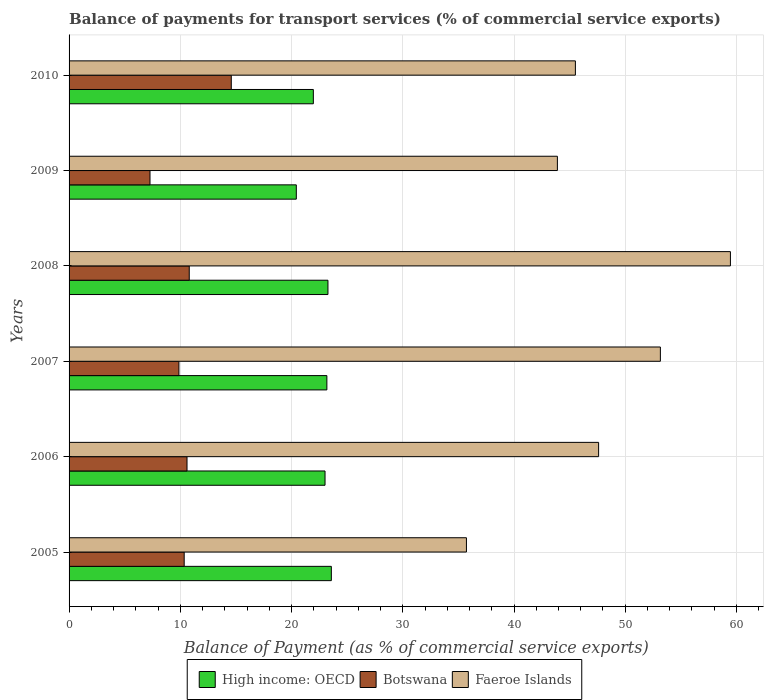How many different coloured bars are there?
Keep it short and to the point. 3. How many groups of bars are there?
Ensure brevity in your answer.  6. Are the number of bars on each tick of the Y-axis equal?
Provide a short and direct response. Yes. How many bars are there on the 5th tick from the top?
Offer a very short reply. 3. What is the label of the 3rd group of bars from the top?
Give a very brief answer. 2008. What is the balance of payments for transport services in Faeroe Islands in 2006?
Offer a terse response. 47.61. Across all years, what is the maximum balance of payments for transport services in Botswana?
Keep it short and to the point. 14.58. Across all years, what is the minimum balance of payments for transport services in Faeroe Islands?
Your response must be concise. 35.72. In which year was the balance of payments for transport services in High income: OECD minimum?
Your answer should be very brief. 2009. What is the total balance of payments for transport services in Faeroe Islands in the graph?
Keep it short and to the point. 285.37. What is the difference between the balance of payments for transport services in High income: OECD in 2006 and that in 2007?
Provide a short and direct response. -0.17. What is the difference between the balance of payments for transport services in High income: OECD in 2005 and the balance of payments for transport services in Botswana in 2009?
Give a very brief answer. 16.3. What is the average balance of payments for transport services in Faeroe Islands per year?
Provide a succinct answer. 47.56. In the year 2009, what is the difference between the balance of payments for transport services in Botswana and balance of payments for transport services in Faeroe Islands?
Offer a terse response. -36.62. What is the ratio of the balance of payments for transport services in Faeroe Islands in 2009 to that in 2010?
Offer a very short reply. 0.96. Is the balance of payments for transport services in Faeroe Islands in 2005 less than that in 2008?
Ensure brevity in your answer.  Yes. What is the difference between the highest and the second highest balance of payments for transport services in Faeroe Islands?
Provide a short and direct response. 6.3. What is the difference between the highest and the lowest balance of payments for transport services in High income: OECD?
Provide a short and direct response. 3.15. In how many years, is the balance of payments for transport services in Botswana greater than the average balance of payments for transport services in Botswana taken over all years?
Provide a short and direct response. 3. Is the sum of the balance of payments for transport services in High income: OECD in 2005 and 2008 greater than the maximum balance of payments for transport services in Faeroe Islands across all years?
Offer a very short reply. No. What does the 2nd bar from the top in 2006 represents?
Your answer should be very brief. Botswana. What does the 2nd bar from the bottom in 2006 represents?
Give a very brief answer. Botswana. Is it the case that in every year, the sum of the balance of payments for transport services in Faeroe Islands and balance of payments for transport services in Botswana is greater than the balance of payments for transport services in High income: OECD?
Offer a very short reply. Yes. How many bars are there?
Offer a terse response. 18. How many years are there in the graph?
Offer a terse response. 6. What is the difference between two consecutive major ticks on the X-axis?
Provide a succinct answer. 10. Are the values on the major ticks of X-axis written in scientific E-notation?
Offer a very short reply. No. What is the title of the graph?
Offer a very short reply. Balance of payments for transport services (% of commercial service exports). Does "Burundi" appear as one of the legend labels in the graph?
Provide a short and direct response. No. What is the label or title of the X-axis?
Give a very brief answer. Balance of Payment (as % of commercial service exports). What is the label or title of the Y-axis?
Ensure brevity in your answer.  Years. What is the Balance of Payment (as % of commercial service exports) in High income: OECD in 2005?
Keep it short and to the point. 23.58. What is the Balance of Payment (as % of commercial service exports) of Botswana in 2005?
Offer a terse response. 10.35. What is the Balance of Payment (as % of commercial service exports) of Faeroe Islands in 2005?
Your response must be concise. 35.72. What is the Balance of Payment (as % of commercial service exports) of High income: OECD in 2006?
Provide a short and direct response. 23.01. What is the Balance of Payment (as % of commercial service exports) in Botswana in 2006?
Your response must be concise. 10.6. What is the Balance of Payment (as % of commercial service exports) of Faeroe Islands in 2006?
Your answer should be compact. 47.61. What is the Balance of Payment (as % of commercial service exports) of High income: OECD in 2007?
Your response must be concise. 23.18. What is the Balance of Payment (as % of commercial service exports) of Botswana in 2007?
Keep it short and to the point. 9.88. What is the Balance of Payment (as % of commercial service exports) in Faeroe Islands in 2007?
Provide a succinct answer. 53.16. What is the Balance of Payment (as % of commercial service exports) of High income: OECD in 2008?
Offer a very short reply. 23.27. What is the Balance of Payment (as % of commercial service exports) of Botswana in 2008?
Keep it short and to the point. 10.8. What is the Balance of Payment (as % of commercial service exports) of Faeroe Islands in 2008?
Ensure brevity in your answer.  59.46. What is the Balance of Payment (as % of commercial service exports) in High income: OECD in 2009?
Ensure brevity in your answer.  20.43. What is the Balance of Payment (as % of commercial service exports) of Botswana in 2009?
Offer a terse response. 7.28. What is the Balance of Payment (as % of commercial service exports) of Faeroe Islands in 2009?
Offer a very short reply. 43.9. What is the Balance of Payment (as % of commercial service exports) of High income: OECD in 2010?
Offer a terse response. 21.96. What is the Balance of Payment (as % of commercial service exports) of Botswana in 2010?
Your answer should be compact. 14.58. What is the Balance of Payment (as % of commercial service exports) in Faeroe Islands in 2010?
Provide a short and direct response. 45.52. Across all years, what is the maximum Balance of Payment (as % of commercial service exports) of High income: OECD?
Make the answer very short. 23.58. Across all years, what is the maximum Balance of Payment (as % of commercial service exports) of Botswana?
Give a very brief answer. 14.58. Across all years, what is the maximum Balance of Payment (as % of commercial service exports) in Faeroe Islands?
Give a very brief answer. 59.46. Across all years, what is the minimum Balance of Payment (as % of commercial service exports) in High income: OECD?
Make the answer very short. 20.43. Across all years, what is the minimum Balance of Payment (as % of commercial service exports) of Botswana?
Provide a succinct answer. 7.28. Across all years, what is the minimum Balance of Payment (as % of commercial service exports) of Faeroe Islands?
Provide a short and direct response. 35.72. What is the total Balance of Payment (as % of commercial service exports) in High income: OECD in the graph?
Your answer should be compact. 135.43. What is the total Balance of Payment (as % of commercial service exports) in Botswana in the graph?
Offer a very short reply. 63.49. What is the total Balance of Payment (as % of commercial service exports) of Faeroe Islands in the graph?
Offer a terse response. 285.37. What is the difference between the Balance of Payment (as % of commercial service exports) in High income: OECD in 2005 and that in 2006?
Keep it short and to the point. 0.57. What is the difference between the Balance of Payment (as % of commercial service exports) of Botswana in 2005 and that in 2006?
Your answer should be compact. -0.25. What is the difference between the Balance of Payment (as % of commercial service exports) of Faeroe Islands in 2005 and that in 2006?
Offer a very short reply. -11.88. What is the difference between the Balance of Payment (as % of commercial service exports) of High income: OECD in 2005 and that in 2007?
Provide a succinct answer. 0.4. What is the difference between the Balance of Payment (as % of commercial service exports) of Botswana in 2005 and that in 2007?
Your response must be concise. 0.47. What is the difference between the Balance of Payment (as % of commercial service exports) in Faeroe Islands in 2005 and that in 2007?
Provide a succinct answer. -17.44. What is the difference between the Balance of Payment (as % of commercial service exports) in High income: OECD in 2005 and that in 2008?
Make the answer very short. 0.31. What is the difference between the Balance of Payment (as % of commercial service exports) in Botswana in 2005 and that in 2008?
Offer a terse response. -0.45. What is the difference between the Balance of Payment (as % of commercial service exports) of Faeroe Islands in 2005 and that in 2008?
Ensure brevity in your answer.  -23.73. What is the difference between the Balance of Payment (as % of commercial service exports) of High income: OECD in 2005 and that in 2009?
Your answer should be very brief. 3.15. What is the difference between the Balance of Payment (as % of commercial service exports) of Botswana in 2005 and that in 2009?
Provide a short and direct response. 3.07. What is the difference between the Balance of Payment (as % of commercial service exports) of Faeroe Islands in 2005 and that in 2009?
Provide a succinct answer. -8.18. What is the difference between the Balance of Payment (as % of commercial service exports) of High income: OECD in 2005 and that in 2010?
Your response must be concise. 1.62. What is the difference between the Balance of Payment (as % of commercial service exports) in Botswana in 2005 and that in 2010?
Provide a short and direct response. -4.23. What is the difference between the Balance of Payment (as % of commercial service exports) in Faeroe Islands in 2005 and that in 2010?
Provide a succinct answer. -9.8. What is the difference between the Balance of Payment (as % of commercial service exports) of High income: OECD in 2006 and that in 2007?
Your answer should be very brief. -0.17. What is the difference between the Balance of Payment (as % of commercial service exports) in Botswana in 2006 and that in 2007?
Provide a short and direct response. 0.73. What is the difference between the Balance of Payment (as % of commercial service exports) in Faeroe Islands in 2006 and that in 2007?
Your answer should be very brief. -5.55. What is the difference between the Balance of Payment (as % of commercial service exports) in High income: OECD in 2006 and that in 2008?
Your response must be concise. -0.26. What is the difference between the Balance of Payment (as % of commercial service exports) in Botswana in 2006 and that in 2008?
Ensure brevity in your answer.  -0.2. What is the difference between the Balance of Payment (as % of commercial service exports) in Faeroe Islands in 2006 and that in 2008?
Provide a short and direct response. -11.85. What is the difference between the Balance of Payment (as % of commercial service exports) in High income: OECD in 2006 and that in 2009?
Ensure brevity in your answer.  2.58. What is the difference between the Balance of Payment (as % of commercial service exports) of Botswana in 2006 and that in 2009?
Make the answer very short. 3.33. What is the difference between the Balance of Payment (as % of commercial service exports) in Faeroe Islands in 2006 and that in 2009?
Your answer should be compact. 3.71. What is the difference between the Balance of Payment (as % of commercial service exports) in High income: OECD in 2006 and that in 2010?
Your answer should be compact. 1.05. What is the difference between the Balance of Payment (as % of commercial service exports) in Botswana in 2006 and that in 2010?
Give a very brief answer. -3.98. What is the difference between the Balance of Payment (as % of commercial service exports) of Faeroe Islands in 2006 and that in 2010?
Offer a very short reply. 2.09. What is the difference between the Balance of Payment (as % of commercial service exports) of High income: OECD in 2007 and that in 2008?
Ensure brevity in your answer.  -0.1. What is the difference between the Balance of Payment (as % of commercial service exports) in Botswana in 2007 and that in 2008?
Provide a succinct answer. -0.93. What is the difference between the Balance of Payment (as % of commercial service exports) in Faeroe Islands in 2007 and that in 2008?
Ensure brevity in your answer.  -6.3. What is the difference between the Balance of Payment (as % of commercial service exports) of High income: OECD in 2007 and that in 2009?
Keep it short and to the point. 2.75. What is the difference between the Balance of Payment (as % of commercial service exports) of Botswana in 2007 and that in 2009?
Offer a very short reply. 2.6. What is the difference between the Balance of Payment (as % of commercial service exports) in Faeroe Islands in 2007 and that in 2009?
Your response must be concise. 9.26. What is the difference between the Balance of Payment (as % of commercial service exports) of High income: OECD in 2007 and that in 2010?
Offer a very short reply. 1.22. What is the difference between the Balance of Payment (as % of commercial service exports) of Botswana in 2007 and that in 2010?
Make the answer very short. -4.71. What is the difference between the Balance of Payment (as % of commercial service exports) of Faeroe Islands in 2007 and that in 2010?
Make the answer very short. 7.64. What is the difference between the Balance of Payment (as % of commercial service exports) in High income: OECD in 2008 and that in 2009?
Your response must be concise. 2.84. What is the difference between the Balance of Payment (as % of commercial service exports) of Botswana in 2008 and that in 2009?
Your answer should be very brief. 3.53. What is the difference between the Balance of Payment (as % of commercial service exports) in Faeroe Islands in 2008 and that in 2009?
Your answer should be very brief. 15.56. What is the difference between the Balance of Payment (as % of commercial service exports) in High income: OECD in 2008 and that in 2010?
Make the answer very short. 1.31. What is the difference between the Balance of Payment (as % of commercial service exports) in Botswana in 2008 and that in 2010?
Offer a terse response. -3.78. What is the difference between the Balance of Payment (as % of commercial service exports) in Faeroe Islands in 2008 and that in 2010?
Your response must be concise. 13.94. What is the difference between the Balance of Payment (as % of commercial service exports) of High income: OECD in 2009 and that in 2010?
Your answer should be very brief. -1.53. What is the difference between the Balance of Payment (as % of commercial service exports) of Botswana in 2009 and that in 2010?
Offer a terse response. -7.31. What is the difference between the Balance of Payment (as % of commercial service exports) in Faeroe Islands in 2009 and that in 2010?
Provide a short and direct response. -1.62. What is the difference between the Balance of Payment (as % of commercial service exports) of High income: OECD in 2005 and the Balance of Payment (as % of commercial service exports) of Botswana in 2006?
Ensure brevity in your answer.  12.98. What is the difference between the Balance of Payment (as % of commercial service exports) in High income: OECD in 2005 and the Balance of Payment (as % of commercial service exports) in Faeroe Islands in 2006?
Provide a short and direct response. -24.03. What is the difference between the Balance of Payment (as % of commercial service exports) of Botswana in 2005 and the Balance of Payment (as % of commercial service exports) of Faeroe Islands in 2006?
Provide a succinct answer. -37.26. What is the difference between the Balance of Payment (as % of commercial service exports) of High income: OECD in 2005 and the Balance of Payment (as % of commercial service exports) of Botswana in 2007?
Your answer should be very brief. 13.7. What is the difference between the Balance of Payment (as % of commercial service exports) of High income: OECD in 2005 and the Balance of Payment (as % of commercial service exports) of Faeroe Islands in 2007?
Your response must be concise. -29.58. What is the difference between the Balance of Payment (as % of commercial service exports) of Botswana in 2005 and the Balance of Payment (as % of commercial service exports) of Faeroe Islands in 2007?
Make the answer very short. -42.81. What is the difference between the Balance of Payment (as % of commercial service exports) of High income: OECD in 2005 and the Balance of Payment (as % of commercial service exports) of Botswana in 2008?
Your answer should be compact. 12.77. What is the difference between the Balance of Payment (as % of commercial service exports) of High income: OECD in 2005 and the Balance of Payment (as % of commercial service exports) of Faeroe Islands in 2008?
Your response must be concise. -35.88. What is the difference between the Balance of Payment (as % of commercial service exports) in Botswana in 2005 and the Balance of Payment (as % of commercial service exports) in Faeroe Islands in 2008?
Give a very brief answer. -49.11. What is the difference between the Balance of Payment (as % of commercial service exports) in High income: OECD in 2005 and the Balance of Payment (as % of commercial service exports) in Botswana in 2009?
Provide a short and direct response. 16.3. What is the difference between the Balance of Payment (as % of commercial service exports) of High income: OECD in 2005 and the Balance of Payment (as % of commercial service exports) of Faeroe Islands in 2009?
Offer a very short reply. -20.32. What is the difference between the Balance of Payment (as % of commercial service exports) in Botswana in 2005 and the Balance of Payment (as % of commercial service exports) in Faeroe Islands in 2009?
Your answer should be very brief. -33.55. What is the difference between the Balance of Payment (as % of commercial service exports) of High income: OECD in 2005 and the Balance of Payment (as % of commercial service exports) of Botswana in 2010?
Give a very brief answer. 9. What is the difference between the Balance of Payment (as % of commercial service exports) in High income: OECD in 2005 and the Balance of Payment (as % of commercial service exports) in Faeroe Islands in 2010?
Provide a succinct answer. -21.94. What is the difference between the Balance of Payment (as % of commercial service exports) of Botswana in 2005 and the Balance of Payment (as % of commercial service exports) of Faeroe Islands in 2010?
Provide a succinct answer. -35.17. What is the difference between the Balance of Payment (as % of commercial service exports) of High income: OECD in 2006 and the Balance of Payment (as % of commercial service exports) of Botswana in 2007?
Your answer should be compact. 13.14. What is the difference between the Balance of Payment (as % of commercial service exports) in High income: OECD in 2006 and the Balance of Payment (as % of commercial service exports) in Faeroe Islands in 2007?
Make the answer very short. -30.15. What is the difference between the Balance of Payment (as % of commercial service exports) of Botswana in 2006 and the Balance of Payment (as % of commercial service exports) of Faeroe Islands in 2007?
Give a very brief answer. -42.56. What is the difference between the Balance of Payment (as % of commercial service exports) of High income: OECD in 2006 and the Balance of Payment (as % of commercial service exports) of Botswana in 2008?
Your answer should be compact. 12.21. What is the difference between the Balance of Payment (as % of commercial service exports) of High income: OECD in 2006 and the Balance of Payment (as % of commercial service exports) of Faeroe Islands in 2008?
Your answer should be very brief. -36.45. What is the difference between the Balance of Payment (as % of commercial service exports) of Botswana in 2006 and the Balance of Payment (as % of commercial service exports) of Faeroe Islands in 2008?
Ensure brevity in your answer.  -48.85. What is the difference between the Balance of Payment (as % of commercial service exports) of High income: OECD in 2006 and the Balance of Payment (as % of commercial service exports) of Botswana in 2009?
Offer a very short reply. 15.74. What is the difference between the Balance of Payment (as % of commercial service exports) of High income: OECD in 2006 and the Balance of Payment (as % of commercial service exports) of Faeroe Islands in 2009?
Your response must be concise. -20.89. What is the difference between the Balance of Payment (as % of commercial service exports) in Botswana in 2006 and the Balance of Payment (as % of commercial service exports) in Faeroe Islands in 2009?
Offer a terse response. -33.3. What is the difference between the Balance of Payment (as % of commercial service exports) in High income: OECD in 2006 and the Balance of Payment (as % of commercial service exports) in Botswana in 2010?
Your answer should be compact. 8.43. What is the difference between the Balance of Payment (as % of commercial service exports) of High income: OECD in 2006 and the Balance of Payment (as % of commercial service exports) of Faeroe Islands in 2010?
Offer a terse response. -22.51. What is the difference between the Balance of Payment (as % of commercial service exports) in Botswana in 2006 and the Balance of Payment (as % of commercial service exports) in Faeroe Islands in 2010?
Your answer should be very brief. -34.92. What is the difference between the Balance of Payment (as % of commercial service exports) of High income: OECD in 2007 and the Balance of Payment (as % of commercial service exports) of Botswana in 2008?
Ensure brevity in your answer.  12.37. What is the difference between the Balance of Payment (as % of commercial service exports) in High income: OECD in 2007 and the Balance of Payment (as % of commercial service exports) in Faeroe Islands in 2008?
Make the answer very short. -36.28. What is the difference between the Balance of Payment (as % of commercial service exports) of Botswana in 2007 and the Balance of Payment (as % of commercial service exports) of Faeroe Islands in 2008?
Ensure brevity in your answer.  -49.58. What is the difference between the Balance of Payment (as % of commercial service exports) of High income: OECD in 2007 and the Balance of Payment (as % of commercial service exports) of Botswana in 2009?
Your answer should be compact. 15.9. What is the difference between the Balance of Payment (as % of commercial service exports) of High income: OECD in 2007 and the Balance of Payment (as % of commercial service exports) of Faeroe Islands in 2009?
Offer a very short reply. -20.72. What is the difference between the Balance of Payment (as % of commercial service exports) of Botswana in 2007 and the Balance of Payment (as % of commercial service exports) of Faeroe Islands in 2009?
Offer a very short reply. -34.02. What is the difference between the Balance of Payment (as % of commercial service exports) of High income: OECD in 2007 and the Balance of Payment (as % of commercial service exports) of Botswana in 2010?
Make the answer very short. 8.59. What is the difference between the Balance of Payment (as % of commercial service exports) of High income: OECD in 2007 and the Balance of Payment (as % of commercial service exports) of Faeroe Islands in 2010?
Keep it short and to the point. -22.34. What is the difference between the Balance of Payment (as % of commercial service exports) of Botswana in 2007 and the Balance of Payment (as % of commercial service exports) of Faeroe Islands in 2010?
Provide a succinct answer. -35.64. What is the difference between the Balance of Payment (as % of commercial service exports) of High income: OECD in 2008 and the Balance of Payment (as % of commercial service exports) of Botswana in 2009?
Your answer should be compact. 16. What is the difference between the Balance of Payment (as % of commercial service exports) in High income: OECD in 2008 and the Balance of Payment (as % of commercial service exports) in Faeroe Islands in 2009?
Offer a very short reply. -20.63. What is the difference between the Balance of Payment (as % of commercial service exports) in Botswana in 2008 and the Balance of Payment (as % of commercial service exports) in Faeroe Islands in 2009?
Ensure brevity in your answer.  -33.1. What is the difference between the Balance of Payment (as % of commercial service exports) in High income: OECD in 2008 and the Balance of Payment (as % of commercial service exports) in Botswana in 2010?
Ensure brevity in your answer.  8.69. What is the difference between the Balance of Payment (as % of commercial service exports) of High income: OECD in 2008 and the Balance of Payment (as % of commercial service exports) of Faeroe Islands in 2010?
Your response must be concise. -22.25. What is the difference between the Balance of Payment (as % of commercial service exports) in Botswana in 2008 and the Balance of Payment (as % of commercial service exports) in Faeroe Islands in 2010?
Give a very brief answer. -34.71. What is the difference between the Balance of Payment (as % of commercial service exports) in High income: OECD in 2009 and the Balance of Payment (as % of commercial service exports) in Botswana in 2010?
Make the answer very short. 5.85. What is the difference between the Balance of Payment (as % of commercial service exports) in High income: OECD in 2009 and the Balance of Payment (as % of commercial service exports) in Faeroe Islands in 2010?
Your answer should be very brief. -25.09. What is the difference between the Balance of Payment (as % of commercial service exports) in Botswana in 2009 and the Balance of Payment (as % of commercial service exports) in Faeroe Islands in 2010?
Make the answer very short. -38.24. What is the average Balance of Payment (as % of commercial service exports) in High income: OECD per year?
Your answer should be very brief. 22.57. What is the average Balance of Payment (as % of commercial service exports) in Botswana per year?
Offer a very short reply. 10.58. What is the average Balance of Payment (as % of commercial service exports) of Faeroe Islands per year?
Make the answer very short. 47.56. In the year 2005, what is the difference between the Balance of Payment (as % of commercial service exports) in High income: OECD and Balance of Payment (as % of commercial service exports) in Botswana?
Provide a short and direct response. 13.23. In the year 2005, what is the difference between the Balance of Payment (as % of commercial service exports) in High income: OECD and Balance of Payment (as % of commercial service exports) in Faeroe Islands?
Make the answer very short. -12.14. In the year 2005, what is the difference between the Balance of Payment (as % of commercial service exports) of Botswana and Balance of Payment (as % of commercial service exports) of Faeroe Islands?
Offer a very short reply. -25.37. In the year 2006, what is the difference between the Balance of Payment (as % of commercial service exports) of High income: OECD and Balance of Payment (as % of commercial service exports) of Botswana?
Your answer should be compact. 12.41. In the year 2006, what is the difference between the Balance of Payment (as % of commercial service exports) of High income: OECD and Balance of Payment (as % of commercial service exports) of Faeroe Islands?
Keep it short and to the point. -24.59. In the year 2006, what is the difference between the Balance of Payment (as % of commercial service exports) in Botswana and Balance of Payment (as % of commercial service exports) in Faeroe Islands?
Ensure brevity in your answer.  -37. In the year 2007, what is the difference between the Balance of Payment (as % of commercial service exports) of High income: OECD and Balance of Payment (as % of commercial service exports) of Botswana?
Keep it short and to the point. 13.3. In the year 2007, what is the difference between the Balance of Payment (as % of commercial service exports) in High income: OECD and Balance of Payment (as % of commercial service exports) in Faeroe Islands?
Provide a succinct answer. -29.98. In the year 2007, what is the difference between the Balance of Payment (as % of commercial service exports) of Botswana and Balance of Payment (as % of commercial service exports) of Faeroe Islands?
Provide a succinct answer. -43.28. In the year 2008, what is the difference between the Balance of Payment (as % of commercial service exports) in High income: OECD and Balance of Payment (as % of commercial service exports) in Botswana?
Your answer should be very brief. 12.47. In the year 2008, what is the difference between the Balance of Payment (as % of commercial service exports) in High income: OECD and Balance of Payment (as % of commercial service exports) in Faeroe Islands?
Your answer should be very brief. -36.18. In the year 2008, what is the difference between the Balance of Payment (as % of commercial service exports) of Botswana and Balance of Payment (as % of commercial service exports) of Faeroe Islands?
Your answer should be very brief. -48.65. In the year 2009, what is the difference between the Balance of Payment (as % of commercial service exports) of High income: OECD and Balance of Payment (as % of commercial service exports) of Botswana?
Your response must be concise. 13.15. In the year 2009, what is the difference between the Balance of Payment (as % of commercial service exports) in High income: OECD and Balance of Payment (as % of commercial service exports) in Faeroe Islands?
Your answer should be very brief. -23.47. In the year 2009, what is the difference between the Balance of Payment (as % of commercial service exports) in Botswana and Balance of Payment (as % of commercial service exports) in Faeroe Islands?
Ensure brevity in your answer.  -36.62. In the year 2010, what is the difference between the Balance of Payment (as % of commercial service exports) in High income: OECD and Balance of Payment (as % of commercial service exports) in Botswana?
Your response must be concise. 7.38. In the year 2010, what is the difference between the Balance of Payment (as % of commercial service exports) of High income: OECD and Balance of Payment (as % of commercial service exports) of Faeroe Islands?
Provide a succinct answer. -23.56. In the year 2010, what is the difference between the Balance of Payment (as % of commercial service exports) in Botswana and Balance of Payment (as % of commercial service exports) in Faeroe Islands?
Make the answer very short. -30.94. What is the ratio of the Balance of Payment (as % of commercial service exports) of High income: OECD in 2005 to that in 2006?
Offer a very short reply. 1.02. What is the ratio of the Balance of Payment (as % of commercial service exports) in Faeroe Islands in 2005 to that in 2006?
Your answer should be compact. 0.75. What is the ratio of the Balance of Payment (as % of commercial service exports) of High income: OECD in 2005 to that in 2007?
Keep it short and to the point. 1.02. What is the ratio of the Balance of Payment (as % of commercial service exports) of Botswana in 2005 to that in 2007?
Give a very brief answer. 1.05. What is the ratio of the Balance of Payment (as % of commercial service exports) in Faeroe Islands in 2005 to that in 2007?
Offer a terse response. 0.67. What is the ratio of the Balance of Payment (as % of commercial service exports) in High income: OECD in 2005 to that in 2008?
Provide a succinct answer. 1.01. What is the ratio of the Balance of Payment (as % of commercial service exports) of Botswana in 2005 to that in 2008?
Offer a very short reply. 0.96. What is the ratio of the Balance of Payment (as % of commercial service exports) of Faeroe Islands in 2005 to that in 2008?
Offer a terse response. 0.6. What is the ratio of the Balance of Payment (as % of commercial service exports) in High income: OECD in 2005 to that in 2009?
Provide a succinct answer. 1.15. What is the ratio of the Balance of Payment (as % of commercial service exports) of Botswana in 2005 to that in 2009?
Ensure brevity in your answer.  1.42. What is the ratio of the Balance of Payment (as % of commercial service exports) of Faeroe Islands in 2005 to that in 2009?
Provide a succinct answer. 0.81. What is the ratio of the Balance of Payment (as % of commercial service exports) in High income: OECD in 2005 to that in 2010?
Ensure brevity in your answer.  1.07. What is the ratio of the Balance of Payment (as % of commercial service exports) in Botswana in 2005 to that in 2010?
Make the answer very short. 0.71. What is the ratio of the Balance of Payment (as % of commercial service exports) in Faeroe Islands in 2005 to that in 2010?
Keep it short and to the point. 0.78. What is the ratio of the Balance of Payment (as % of commercial service exports) of Botswana in 2006 to that in 2007?
Provide a short and direct response. 1.07. What is the ratio of the Balance of Payment (as % of commercial service exports) of Faeroe Islands in 2006 to that in 2007?
Your response must be concise. 0.9. What is the ratio of the Balance of Payment (as % of commercial service exports) of Botswana in 2006 to that in 2008?
Make the answer very short. 0.98. What is the ratio of the Balance of Payment (as % of commercial service exports) in Faeroe Islands in 2006 to that in 2008?
Provide a succinct answer. 0.8. What is the ratio of the Balance of Payment (as % of commercial service exports) of High income: OECD in 2006 to that in 2009?
Ensure brevity in your answer.  1.13. What is the ratio of the Balance of Payment (as % of commercial service exports) in Botswana in 2006 to that in 2009?
Give a very brief answer. 1.46. What is the ratio of the Balance of Payment (as % of commercial service exports) of Faeroe Islands in 2006 to that in 2009?
Keep it short and to the point. 1.08. What is the ratio of the Balance of Payment (as % of commercial service exports) in High income: OECD in 2006 to that in 2010?
Provide a short and direct response. 1.05. What is the ratio of the Balance of Payment (as % of commercial service exports) of Botswana in 2006 to that in 2010?
Ensure brevity in your answer.  0.73. What is the ratio of the Balance of Payment (as % of commercial service exports) in Faeroe Islands in 2006 to that in 2010?
Your response must be concise. 1.05. What is the ratio of the Balance of Payment (as % of commercial service exports) of Botswana in 2007 to that in 2008?
Offer a very short reply. 0.91. What is the ratio of the Balance of Payment (as % of commercial service exports) of Faeroe Islands in 2007 to that in 2008?
Your answer should be compact. 0.89. What is the ratio of the Balance of Payment (as % of commercial service exports) in High income: OECD in 2007 to that in 2009?
Your answer should be very brief. 1.13. What is the ratio of the Balance of Payment (as % of commercial service exports) in Botswana in 2007 to that in 2009?
Your response must be concise. 1.36. What is the ratio of the Balance of Payment (as % of commercial service exports) of Faeroe Islands in 2007 to that in 2009?
Provide a short and direct response. 1.21. What is the ratio of the Balance of Payment (as % of commercial service exports) of High income: OECD in 2007 to that in 2010?
Ensure brevity in your answer.  1.06. What is the ratio of the Balance of Payment (as % of commercial service exports) of Botswana in 2007 to that in 2010?
Provide a succinct answer. 0.68. What is the ratio of the Balance of Payment (as % of commercial service exports) of Faeroe Islands in 2007 to that in 2010?
Make the answer very short. 1.17. What is the ratio of the Balance of Payment (as % of commercial service exports) in High income: OECD in 2008 to that in 2009?
Ensure brevity in your answer.  1.14. What is the ratio of the Balance of Payment (as % of commercial service exports) of Botswana in 2008 to that in 2009?
Offer a very short reply. 1.48. What is the ratio of the Balance of Payment (as % of commercial service exports) of Faeroe Islands in 2008 to that in 2009?
Provide a short and direct response. 1.35. What is the ratio of the Balance of Payment (as % of commercial service exports) of High income: OECD in 2008 to that in 2010?
Offer a very short reply. 1.06. What is the ratio of the Balance of Payment (as % of commercial service exports) in Botswana in 2008 to that in 2010?
Your answer should be compact. 0.74. What is the ratio of the Balance of Payment (as % of commercial service exports) in Faeroe Islands in 2008 to that in 2010?
Ensure brevity in your answer.  1.31. What is the ratio of the Balance of Payment (as % of commercial service exports) of High income: OECD in 2009 to that in 2010?
Ensure brevity in your answer.  0.93. What is the ratio of the Balance of Payment (as % of commercial service exports) in Botswana in 2009 to that in 2010?
Provide a succinct answer. 0.5. What is the ratio of the Balance of Payment (as % of commercial service exports) of Faeroe Islands in 2009 to that in 2010?
Give a very brief answer. 0.96. What is the difference between the highest and the second highest Balance of Payment (as % of commercial service exports) of High income: OECD?
Offer a terse response. 0.31. What is the difference between the highest and the second highest Balance of Payment (as % of commercial service exports) in Botswana?
Provide a succinct answer. 3.78. What is the difference between the highest and the second highest Balance of Payment (as % of commercial service exports) of Faeroe Islands?
Provide a succinct answer. 6.3. What is the difference between the highest and the lowest Balance of Payment (as % of commercial service exports) in High income: OECD?
Your response must be concise. 3.15. What is the difference between the highest and the lowest Balance of Payment (as % of commercial service exports) of Botswana?
Your answer should be very brief. 7.31. What is the difference between the highest and the lowest Balance of Payment (as % of commercial service exports) of Faeroe Islands?
Offer a very short reply. 23.73. 